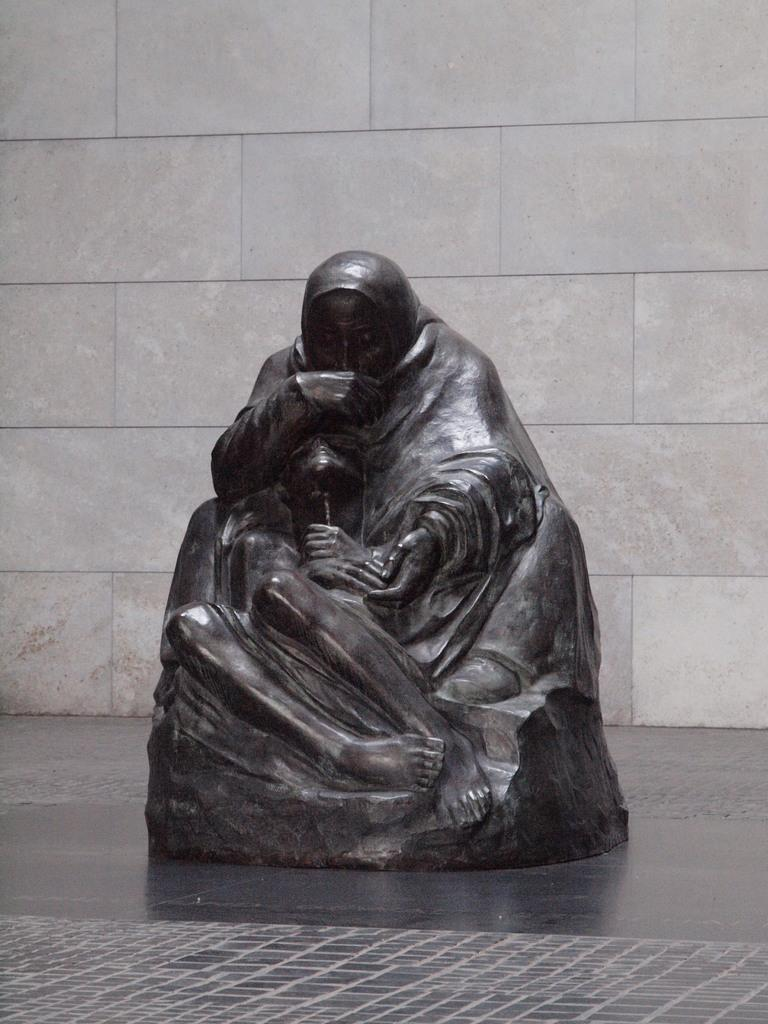What is placed on the floor in the image? There is a sculpture on the floor in the image. What can be seen in the background of the image? There is a wall visible in the image. What type of instrument is being played by the sculpture in the image? There is no instrument being played by the sculpture in the image, as it is a static object and not a living being. 